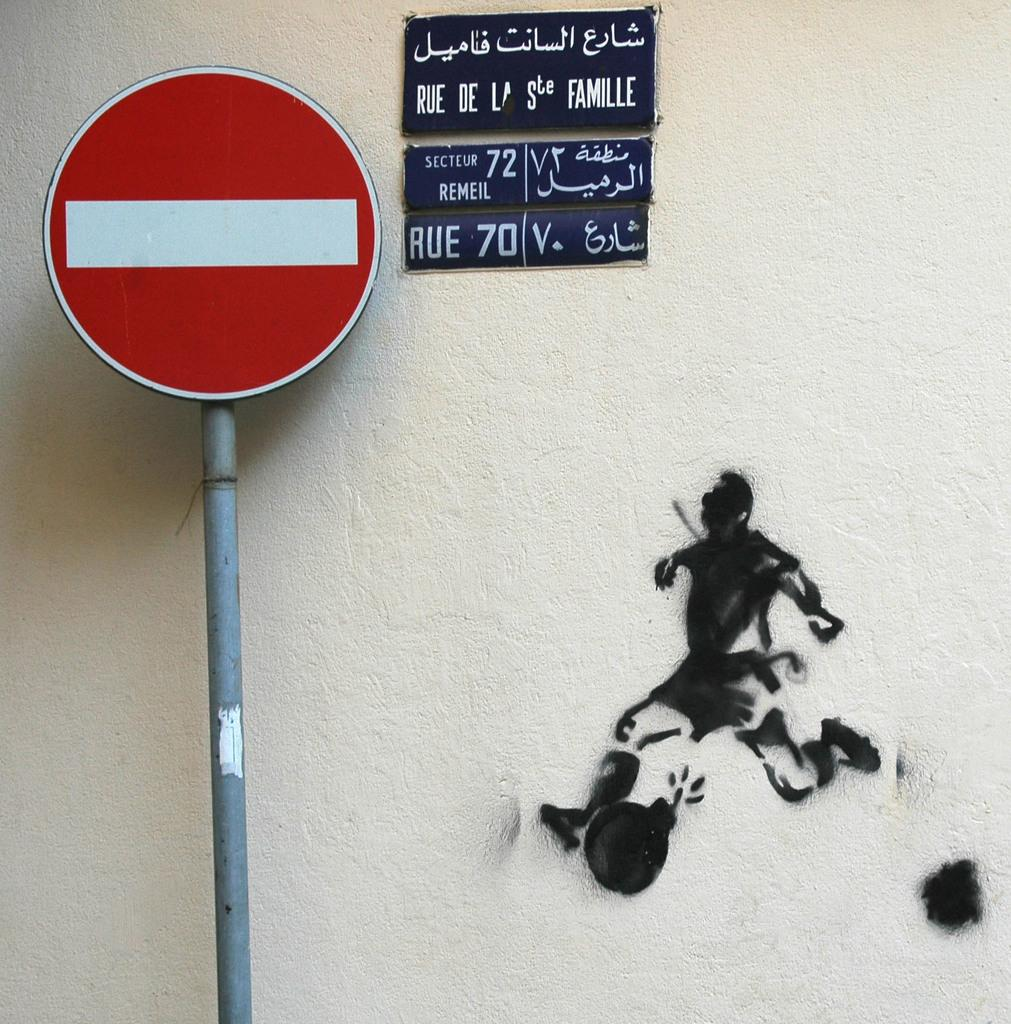<image>
Offer a succinct explanation of the picture presented. A red street sign is next to a sign for RUE 70. 